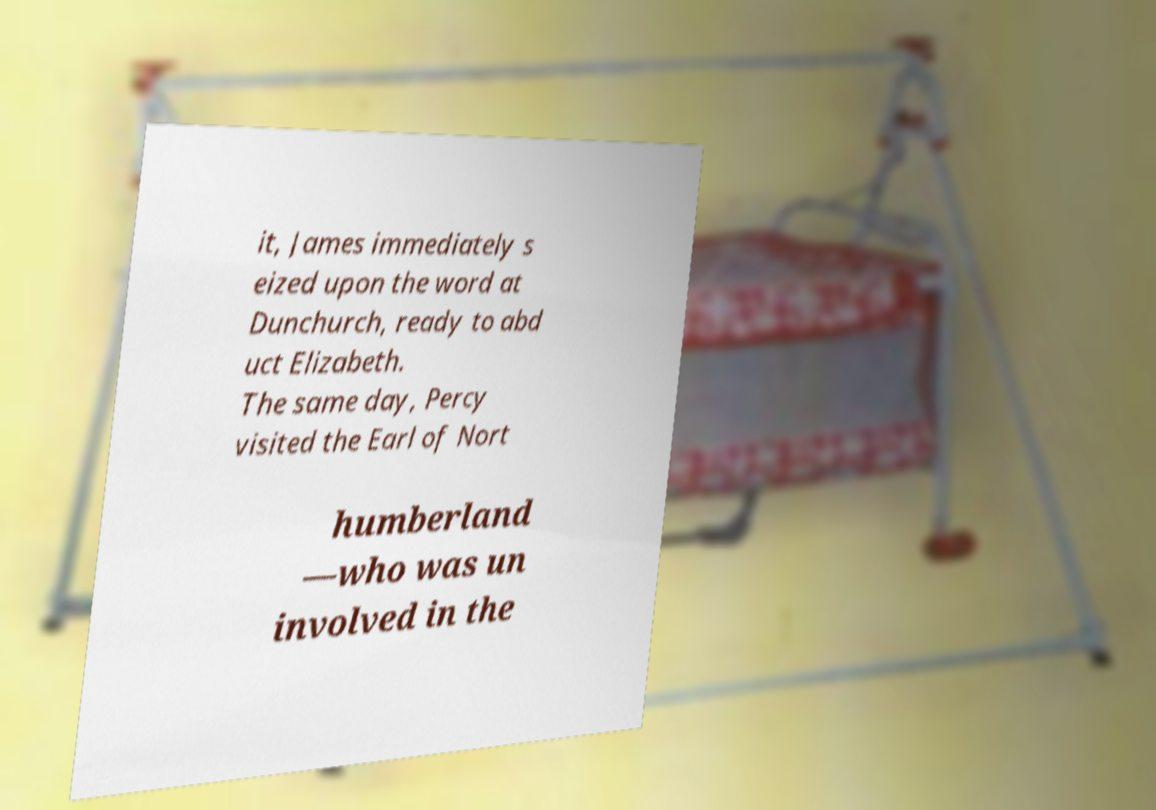There's text embedded in this image that I need extracted. Can you transcribe it verbatim? it, James immediately s eized upon the word at Dunchurch, ready to abd uct Elizabeth. The same day, Percy visited the Earl of Nort humberland —who was un involved in the 